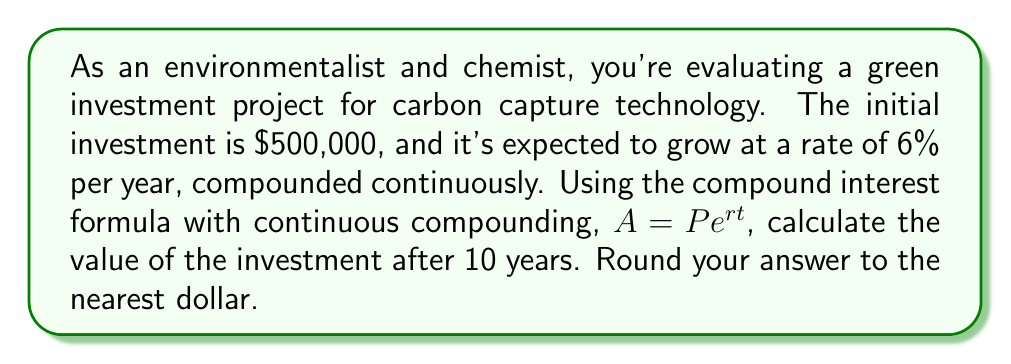Help me with this question. To solve this problem, we'll use the compound interest formula for continuous compounding:

$$A = Pe^{rt}$$

Where:
$A$ = final amount
$P$ = principal (initial investment)
$e$ = Euler's number (approximately 2.71828)
$r$ = annual interest rate (as a decimal)
$t$ = time in years

Given:
$P = \$500,000$
$r = 6\% = 0.06$
$t = 10$ years

Let's substitute these values into the formula:

$$A = 500,000 \cdot e^{0.06 \cdot 10}$$

Now, let's calculate:

$$A = 500,000 \cdot e^{0.6}$$

Using a calculator or computer to evaluate $e^{0.6}$:

$$A = 500,000 \cdot 1.8221188$$

$$A = 911,059.40$$

Rounding to the nearest dollar:

$$A = \$911,059$$
Answer: $911,059 